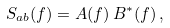Convert formula to latex. <formula><loc_0><loc_0><loc_500><loc_500>S _ { a b } ( f ) = A ( f ) \, B ^ { \ast } ( f ) \, ,</formula> 